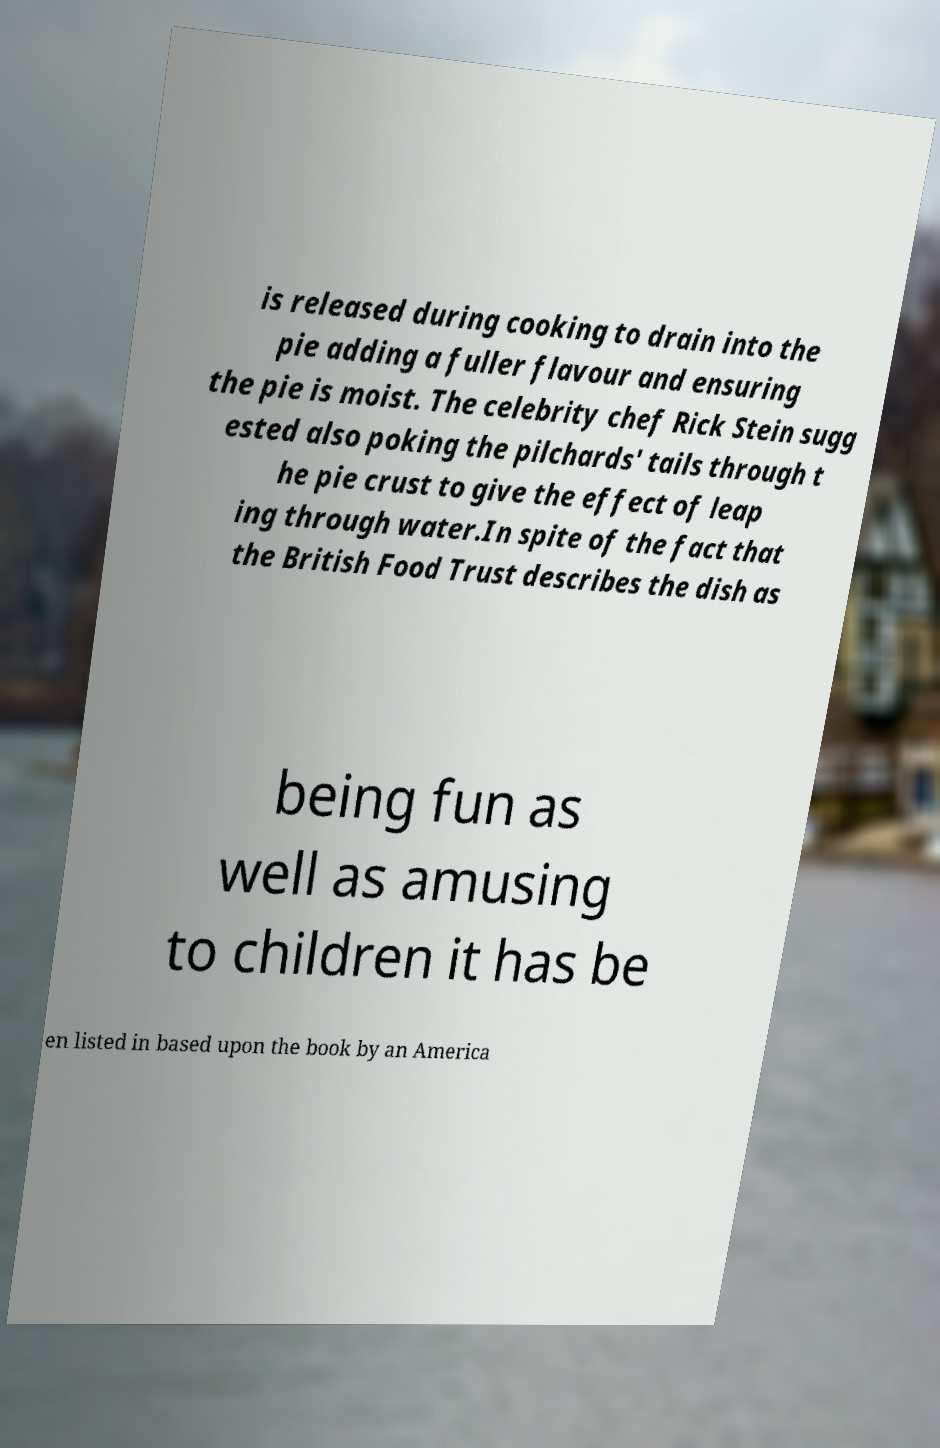Please identify and transcribe the text found in this image. is released during cooking to drain into the pie adding a fuller flavour and ensuring the pie is moist. The celebrity chef Rick Stein sugg ested also poking the pilchards' tails through t he pie crust to give the effect of leap ing through water.In spite of the fact that the British Food Trust describes the dish as being fun as well as amusing to children it has be en listed in based upon the book by an America 